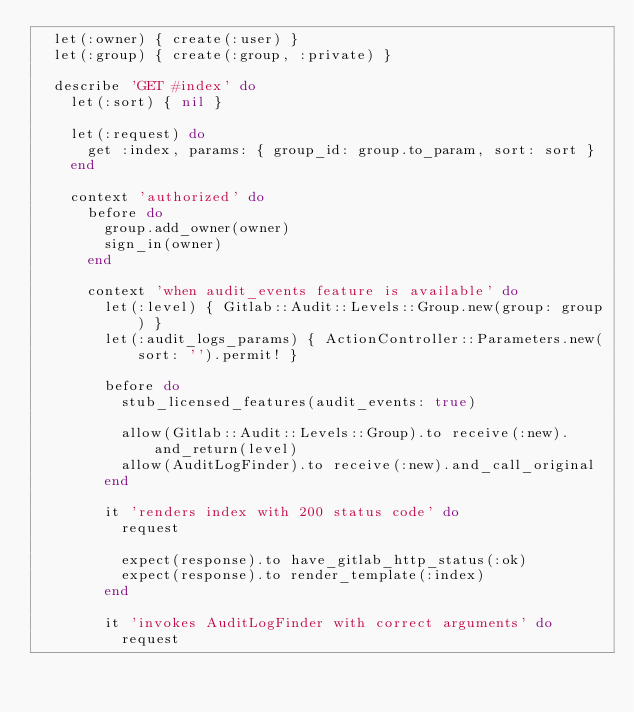<code> <loc_0><loc_0><loc_500><loc_500><_Ruby_>  let(:owner) { create(:user) }
  let(:group) { create(:group, :private) }

  describe 'GET #index' do
    let(:sort) { nil }

    let(:request) do
      get :index, params: { group_id: group.to_param, sort: sort }
    end

    context 'authorized' do
      before do
        group.add_owner(owner)
        sign_in(owner)
      end

      context 'when audit_events feature is available' do
        let(:level) { Gitlab::Audit::Levels::Group.new(group: group) }
        let(:audit_logs_params) { ActionController::Parameters.new(sort: '').permit! }

        before do
          stub_licensed_features(audit_events: true)

          allow(Gitlab::Audit::Levels::Group).to receive(:new).and_return(level)
          allow(AuditLogFinder).to receive(:new).and_call_original
        end

        it 'renders index with 200 status code' do
          request

          expect(response).to have_gitlab_http_status(:ok)
          expect(response).to render_template(:index)
        end

        it 'invokes AuditLogFinder with correct arguments' do
          request
</code> 